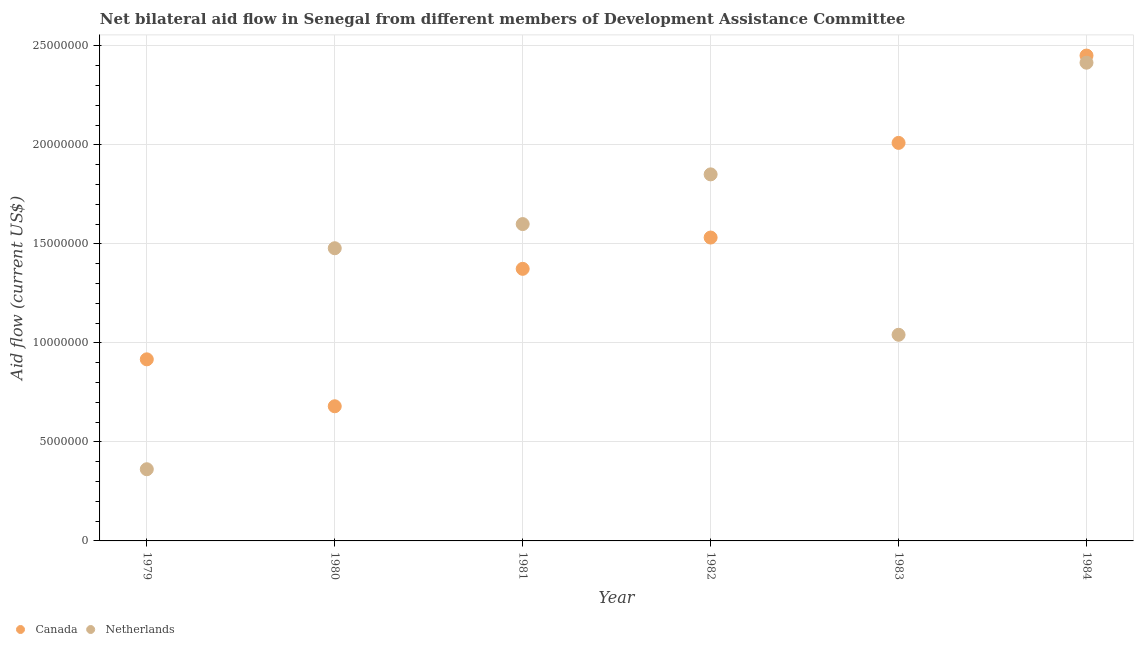What is the amount of aid given by netherlands in 1981?
Provide a succinct answer. 1.60e+07. Across all years, what is the maximum amount of aid given by netherlands?
Your answer should be compact. 2.42e+07. Across all years, what is the minimum amount of aid given by canada?
Make the answer very short. 6.80e+06. In which year was the amount of aid given by canada maximum?
Provide a succinct answer. 1984. What is the total amount of aid given by netherlands in the graph?
Make the answer very short. 8.75e+07. What is the difference between the amount of aid given by canada in 1983 and that in 1984?
Make the answer very short. -4.41e+06. What is the difference between the amount of aid given by netherlands in 1982 and the amount of aid given by canada in 1983?
Give a very brief answer. -1.59e+06. What is the average amount of aid given by canada per year?
Your answer should be compact. 1.49e+07. In the year 1982, what is the difference between the amount of aid given by netherlands and amount of aid given by canada?
Give a very brief answer. 3.19e+06. In how many years, is the amount of aid given by netherlands greater than 9000000 US$?
Provide a short and direct response. 5. What is the ratio of the amount of aid given by netherlands in 1979 to that in 1980?
Your response must be concise. 0.24. Is the difference between the amount of aid given by canada in 1982 and 1984 greater than the difference between the amount of aid given by netherlands in 1982 and 1984?
Give a very brief answer. No. What is the difference between the highest and the second highest amount of aid given by canada?
Ensure brevity in your answer.  4.41e+06. What is the difference between the highest and the lowest amount of aid given by netherlands?
Ensure brevity in your answer.  2.05e+07. In how many years, is the amount of aid given by netherlands greater than the average amount of aid given by netherlands taken over all years?
Offer a terse response. 4. Is the amount of aid given by canada strictly greater than the amount of aid given by netherlands over the years?
Your answer should be very brief. No. How many dotlines are there?
Offer a terse response. 2. Are the values on the major ticks of Y-axis written in scientific E-notation?
Give a very brief answer. No. Does the graph contain grids?
Offer a terse response. Yes. Where does the legend appear in the graph?
Provide a short and direct response. Bottom left. How many legend labels are there?
Give a very brief answer. 2. How are the legend labels stacked?
Provide a short and direct response. Horizontal. What is the title of the graph?
Your answer should be compact. Net bilateral aid flow in Senegal from different members of Development Assistance Committee. What is the label or title of the X-axis?
Your response must be concise. Year. What is the Aid flow (current US$) in Canada in 1979?
Ensure brevity in your answer.  9.17e+06. What is the Aid flow (current US$) in Netherlands in 1979?
Your answer should be very brief. 3.62e+06. What is the Aid flow (current US$) of Canada in 1980?
Provide a succinct answer. 6.80e+06. What is the Aid flow (current US$) of Netherlands in 1980?
Keep it short and to the point. 1.48e+07. What is the Aid flow (current US$) in Canada in 1981?
Provide a short and direct response. 1.37e+07. What is the Aid flow (current US$) in Netherlands in 1981?
Offer a terse response. 1.60e+07. What is the Aid flow (current US$) in Canada in 1982?
Provide a short and direct response. 1.53e+07. What is the Aid flow (current US$) in Netherlands in 1982?
Make the answer very short. 1.85e+07. What is the Aid flow (current US$) of Canada in 1983?
Make the answer very short. 2.01e+07. What is the Aid flow (current US$) in Netherlands in 1983?
Provide a short and direct response. 1.04e+07. What is the Aid flow (current US$) of Canada in 1984?
Keep it short and to the point. 2.45e+07. What is the Aid flow (current US$) of Netherlands in 1984?
Ensure brevity in your answer.  2.42e+07. Across all years, what is the maximum Aid flow (current US$) in Canada?
Give a very brief answer. 2.45e+07. Across all years, what is the maximum Aid flow (current US$) in Netherlands?
Ensure brevity in your answer.  2.42e+07. Across all years, what is the minimum Aid flow (current US$) in Canada?
Make the answer very short. 6.80e+06. Across all years, what is the minimum Aid flow (current US$) of Netherlands?
Your answer should be very brief. 3.62e+06. What is the total Aid flow (current US$) in Canada in the graph?
Your answer should be compact. 8.96e+07. What is the total Aid flow (current US$) in Netherlands in the graph?
Provide a succinct answer. 8.75e+07. What is the difference between the Aid flow (current US$) of Canada in 1979 and that in 1980?
Make the answer very short. 2.37e+06. What is the difference between the Aid flow (current US$) in Netherlands in 1979 and that in 1980?
Provide a short and direct response. -1.12e+07. What is the difference between the Aid flow (current US$) in Canada in 1979 and that in 1981?
Your answer should be very brief. -4.57e+06. What is the difference between the Aid flow (current US$) of Netherlands in 1979 and that in 1981?
Make the answer very short. -1.24e+07. What is the difference between the Aid flow (current US$) of Canada in 1979 and that in 1982?
Keep it short and to the point. -6.15e+06. What is the difference between the Aid flow (current US$) in Netherlands in 1979 and that in 1982?
Keep it short and to the point. -1.49e+07. What is the difference between the Aid flow (current US$) in Canada in 1979 and that in 1983?
Your answer should be very brief. -1.09e+07. What is the difference between the Aid flow (current US$) of Netherlands in 1979 and that in 1983?
Give a very brief answer. -6.79e+06. What is the difference between the Aid flow (current US$) of Canada in 1979 and that in 1984?
Offer a very short reply. -1.53e+07. What is the difference between the Aid flow (current US$) in Netherlands in 1979 and that in 1984?
Ensure brevity in your answer.  -2.05e+07. What is the difference between the Aid flow (current US$) in Canada in 1980 and that in 1981?
Offer a very short reply. -6.94e+06. What is the difference between the Aid flow (current US$) of Netherlands in 1980 and that in 1981?
Offer a terse response. -1.22e+06. What is the difference between the Aid flow (current US$) of Canada in 1980 and that in 1982?
Your answer should be very brief. -8.52e+06. What is the difference between the Aid flow (current US$) of Netherlands in 1980 and that in 1982?
Your response must be concise. -3.73e+06. What is the difference between the Aid flow (current US$) of Canada in 1980 and that in 1983?
Offer a terse response. -1.33e+07. What is the difference between the Aid flow (current US$) in Netherlands in 1980 and that in 1983?
Make the answer very short. 4.37e+06. What is the difference between the Aid flow (current US$) of Canada in 1980 and that in 1984?
Provide a short and direct response. -1.77e+07. What is the difference between the Aid flow (current US$) in Netherlands in 1980 and that in 1984?
Provide a short and direct response. -9.37e+06. What is the difference between the Aid flow (current US$) of Canada in 1981 and that in 1982?
Your response must be concise. -1.58e+06. What is the difference between the Aid flow (current US$) of Netherlands in 1981 and that in 1982?
Your answer should be compact. -2.51e+06. What is the difference between the Aid flow (current US$) in Canada in 1981 and that in 1983?
Your response must be concise. -6.36e+06. What is the difference between the Aid flow (current US$) of Netherlands in 1981 and that in 1983?
Provide a short and direct response. 5.59e+06. What is the difference between the Aid flow (current US$) of Canada in 1981 and that in 1984?
Provide a short and direct response. -1.08e+07. What is the difference between the Aid flow (current US$) of Netherlands in 1981 and that in 1984?
Your response must be concise. -8.15e+06. What is the difference between the Aid flow (current US$) of Canada in 1982 and that in 1983?
Give a very brief answer. -4.78e+06. What is the difference between the Aid flow (current US$) of Netherlands in 1982 and that in 1983?
Offer a terse response. 8.10e+06. What is the difference between the Aid flow (current US$) in Canada in 1982 and that in 1984?
Offer a terse response. -9.19e+06. What is the difference between the Aid flow (current US$) of Netherlands in 1982 and that in 1984?
Your answer should be very brief. -5.64e+06. What is the difference between the Aid flow (current US$) in Canada in 1983 and that in 1984?
Your answer should be compact. -4.41e+06. What is the difference between the Aid flow (current US$) of Netherlands in 1983 and that in 1984?
Your response must be concise. -1.37e+07. What is the difference between the Aid flow (current US$) in Canada in 1979 and the Aid flow (current US$) in Netherlands in 1980?
Provide a short and direct response. -5.61e+06. What is the difference between the Aid flow (current US$) in Canada in 1979 and the Aid flow (current US$) in Netherlands in 1981?
Keep it short and to the point. -6.83e+06. What is the difference between the Aid flow (current US$) in Canada in 1979 and the Aid flow (current US$) in Netherlands in 1982?
Your response must be concise. -9.34e+06. What is the difference between the Aid flow (current US$) of Canada in 1979 and the Aid flow (current US$) of Netherlands in 1983?
Ensure brevity in your answer.  -1.24e+06. What is the difference between the Aid flow (current US$) in Canada in 1979 and the Aid flow (current US$) in Netherlands in 1984?
Ensure brevity in your answer.  -1.50e+07. What is the difference between the Aid flow (current US$) of Canada in 1980 and the Aid flow (current US$) of Netherlands in 1981?
Your answer should be very brief. -9.20e+06. What is the difference between the Aid flow (current US$) in Canada in 1980 and the Aid flow (current US$) in Netherlands in 1982?
Provide a succinct answer. -1.17e+07. What is the difference between the Aid flow (current US$) of Canada in 1980 and the Aid flow (current US$) of Netherlands in 1983?
Your response must be concise. -3.61e+06. What is the difference between the Aid flow (current US$) of Canada in 1980 and the Aid flow (current US$) of Netherlands in 1984?
Offer a terse response. -1.74e+07. What is the difference between the Aid flow (current US$) in Canada in 1981 and the Aid flow (current US$) in Netherlands in 1982?
Keep it short and to the point. -4.77e+06. What is the difference between the Aid flow (current US$) of Canada in 1981 and the Aid flow (current US$) of Netherlands in 1983?
Your response must be concise. 3.33e+06. What is the difference between the Aid flow (current US$) in Canada in 1981 and the Aid flow (current US$) in Netherlands in 1984?
Keep it short and to the point. -1.04e+07. What is the difference between the Aid flow (current US$) in Canada in 1982 and the Aid flow (current US$) in Netherlands in 1983?
Provide a short and direct response. 4.91e+06. What is the difference between the Aid flow (current US$) in Canada in 1982 and the Aid flow (current US$) in Netherlands in 1984?
Provide a succinct answer. -8.83e+06. What is the difference between the Aid flow (current US$) of Canada in 1983 and the Aid flow (current US$) of Netherlands in 1984?
Keep it short and to the point. -4.05e+06. What is the average Aid flow (current US$) of Canada per year?
Provide a succinct answer. 1.49e+07. What is the average Aid flow (current US$) in Netherlands per year?
Your answer should be compact. 1.46e+07. In the year 1979, what is the difference between the Aid flow (current US$) of Canada and Aid flow (current US$) of Netherlands?
Your answer should be compact. 5.55e+06. In the year 1980, what is the difference between the Aid flow (current US$) of Canada and Aid flow (current US$) of Netherlands?
Offer a very short reply. -7.98e+06. In the year 1981, what is the difference between the Aid flow (current US$) of Canada and Aid flow (current US$) of Netherlands?
Offer a terse response. -2.26e+06. In the year 1982, what is the difference between the Aid flow (current US$) of Canada and Aid flow (current US$) of Netherlands?
Your response must be concise. -3.19e+06. In the year 1983, what is the difference between the Aid flow (current US$) of Canada and Aid flow (current US$) of Netherlands?
Keep it short and to the point. 9.69e+06. In the year 1984, what is the difference between the Aid flow (current US$) in Canada and Aid flow (current US$) in Netherlands?
Your response must be concise. 3.60e+05. What is the ratio of the Aid flow (current US$) in Canada in 1979 to that in 1980?
Your response must be concise. 1.35. What is the ratio of the Aid flow (current US$) of Netherlands in 1979 to that in 1980?
Your response must be concise. 0.24. What is the ratio of the Aid flow (current US$) in Canada in 1979 to that in 1981?
Ensure brevity in your answer.  0.67. What is the ratio of the Aid flow (current US$) of Netherlands in 1979 to that in 1981?
Give a very brief answer. 0.23. What is the ratio of the Aid flow (current US$) of Canada in 1979 to that in 1982?
Offer a terse response. 0.6. What is the ratio of the Aid flow (current US$) in Netherlands in 1979 to that in 1982?
Your response must be concise. 0.2. What is the ratio of the Aid flow (current US$) of Canada in 1979 to that in 1983?
Keep it short and to the point. 0.46. What is the ratio of the Aid flow (current US$) of Netherlands in 1979 to that in 1983?
Ensure brevity in your answer.  0.35. What is the ratio of the Aid flow (current US$) of Canada in 1979 to that in 1984?
Provide a succinct answer. 0.37. What is the ratio of the Aid flow (current US$) in Netherlands in 1979 to that in 1984?
Ensure brevity in your answer.  0.15. What is the ratio of the Aid flow (current US$) of Canada in 1980 to that in 1981?
Your response must be concise. 0.49. What is the ratio of the Aid flow (current US$) of Netherlands in 1980 to that in 1981?
Your answer should be compact. 0.92. What is the ratio of the Aid flow (current US$) in Canada in 1980 to that in 1982?
Offer a very short reply. 0.44. What is the ratio of the Aid flow (current US$) of Netherlands in 1980 to that in 1982?
Offer a terse response. 0.8. What is the ratio of the Aid flow (current US$) of Canada in 1980 to that in 1983?
Give a very brief answer. 0.34. What is the ratio of the Aid flow (current US$) in Netherlands in 1980 to that in 1983?
Keep it short and to the point. 1.42. What is the ratio of the Aid flow (current US$) of Canada in 1980 to that in 1984?
Ensure brevity in your answer.  0.28. What is the ratio of the Aid flow (current US$) of Netherlands in 1980 to that in 1984?
Your answer should be compact. 0.61. What is the ratio of the Aid flow (current US$) of Canada in 1981 to that in 1982?
Give a very brief answer. 0.9. What is the ratio of the Aid flow (current US$) of Netherlands in 1981 to that in 1982?
Provide a succinct answer. 0.86. What is the ratio of the Aid flow (current US$) of Canada in 1981 to that in 1983?
Provide a succinct answer. 0.68. What is the ratio of the Aid flow (current US$) of Netherlands in 1981 to that in 1983?
Offer a terse response. 1.54. What is the ratio of the Aid flow (current US$) in Canada in 1981 to that in 1984?
Your response must be concise. 0.56. What is the ratio of the Aid flow (current US$) in Netherlands in 1981 to that in 1984?
Ensure brevity in your answer.  0.66. What is the ratio of the Aid flow (current US$) of Canada in 1982 to that in 1983?
Your answer should be very brief. 0.76. What is the ratio of the Aid flow (current US$) of Netherlands in 1982 to that in 1983?
Give a very brief answer. 1.78. What is the ratio of the Aid flow (current US$) of Canada in 1982 to that in 1984?
Offer a terse response. 0.63. What is the ratio of the Aid flow (current US$) in Netherlands in 1982 to that in 1984?
Ensure brevity in your answer.  0.77. What is the ratio of the Aid flow (current US$) in Canada in 1983 to that in 1984?
Your answer should be compact. 0.82. What is the ratio of the Aid flow (current US$) of Netherlands in 1983 to that in 1984?
Make the answer very short. 0.43. What is the difference between the highest and the second highest Aid flow (current US$) of Canada?
Provide a succinct answer. 4.41e+06. What is the difference between the highest and the second highest Aid flow (current US$) in Netherlands?
Keep it short and to the point. 5.64e+06. What is the difference between the highest and the lowest Aid flow (current US$) of Canada?
Keep it short and to the point. 1.77e+07. What is the difference between the highest and the lowest Aid flow (current US$) in Netherlands?
Provide a short and direct response. 2.05e+07. 